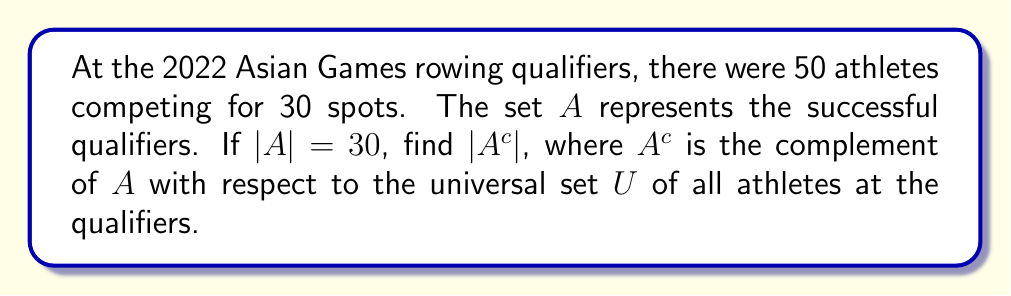Can you solve this math problem? To solve this problem, we need to understand the following concepts:

1. The universal set $U$ contains all elements in the given context.
2. The complement of a set $A$, denoted as $A^c$, contains all elements in $U$ that are not in $A$.
3. The number of elements in a set is denoted by $|A|$.

Let's solve this step-by-step:

1. Define the universal set $U$:
   $U$ = {all athletes at the qualifiers}
   $|U| = 50$

2. Given information about set $A$:
   $A$ = {successful qualifiers}
   $|A| = 30$

3. The complement of $A$ ($A^c$) contains all elements in $U$ that are not in $A$. In this case, it represents the athletes who did not qualify.

4. To find $|A^c|$, we can use the following formula:
   $|A^c| = |U| - |A|$

5. Substituting the values:
   $|A^c| = 50 - 30 = 20$

Therefore, the number of athletes in the complement set $A^c$ is 20.
Answer: $|A^c| = 20$ 